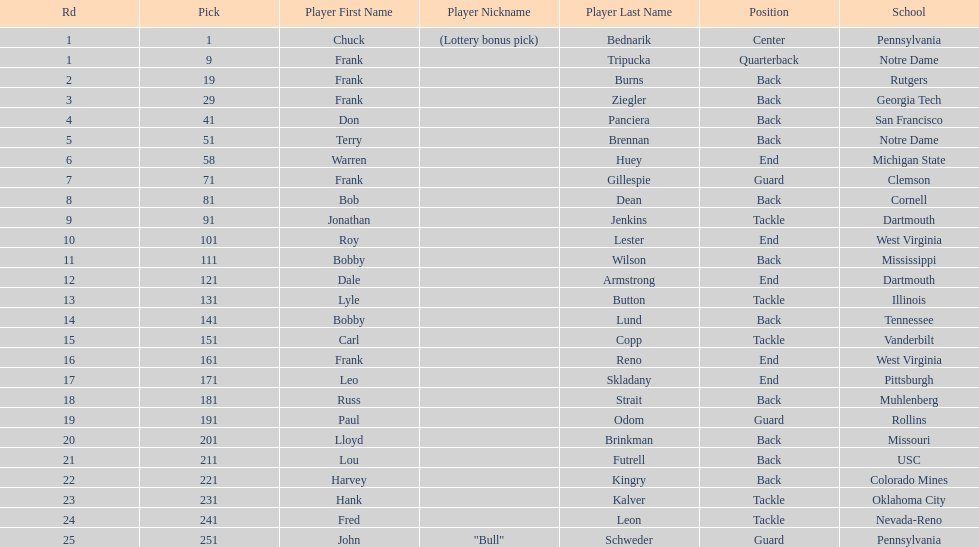Highest rd number? 25. 